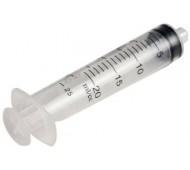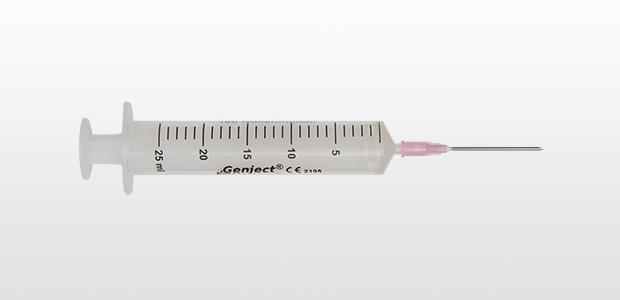The first image is the image on the left, the second image is the image on the right. Considering the images on both sides, is "There are 3 or fewer syringes total." valid? Answer yes or no. Yes. The first image is the image on the left, the second image is the image on the right. Considering the images on both sides, is "There is exactly one syringe in the left image." valid? Answer yes or no. Yes. 